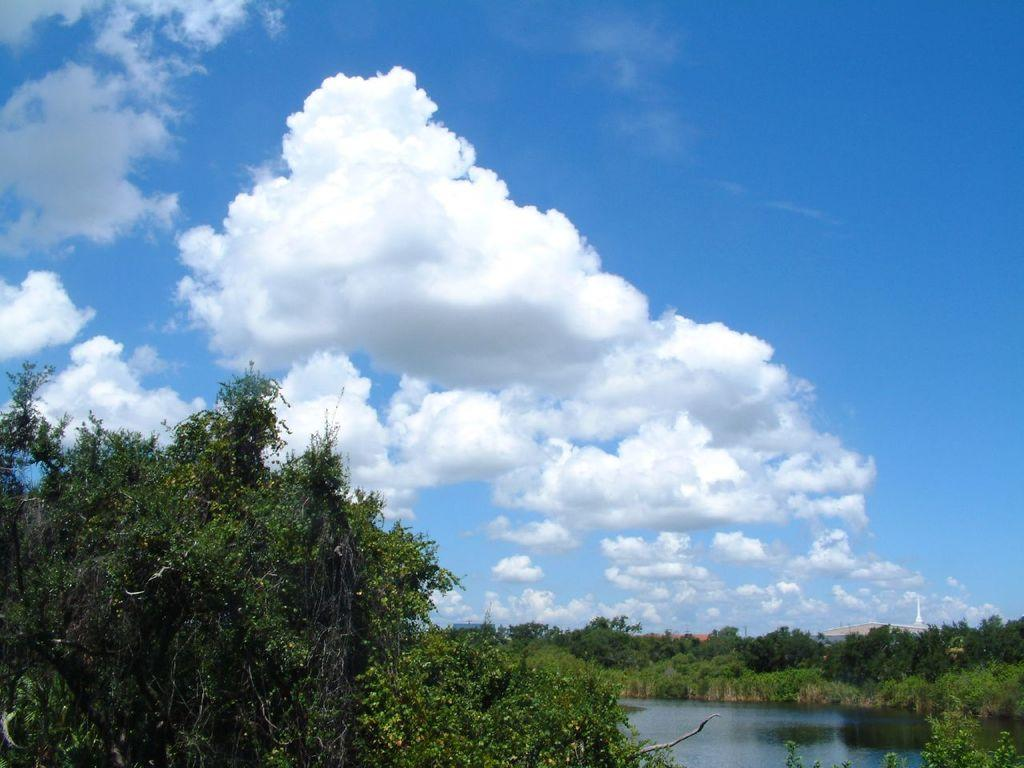What is the main feature in the middle of the image? There is a lake in the middle of the image. What surrounds the lake in the image? There are trees on either side of the lake. What can be seen at the top of the image? The sky is visible at the top of the image. What is present in the sky? Clouds are present in the sky. What letters can be seen on the camera in the image? There is no camera present in the image, so there are no letters to be seen on it. 